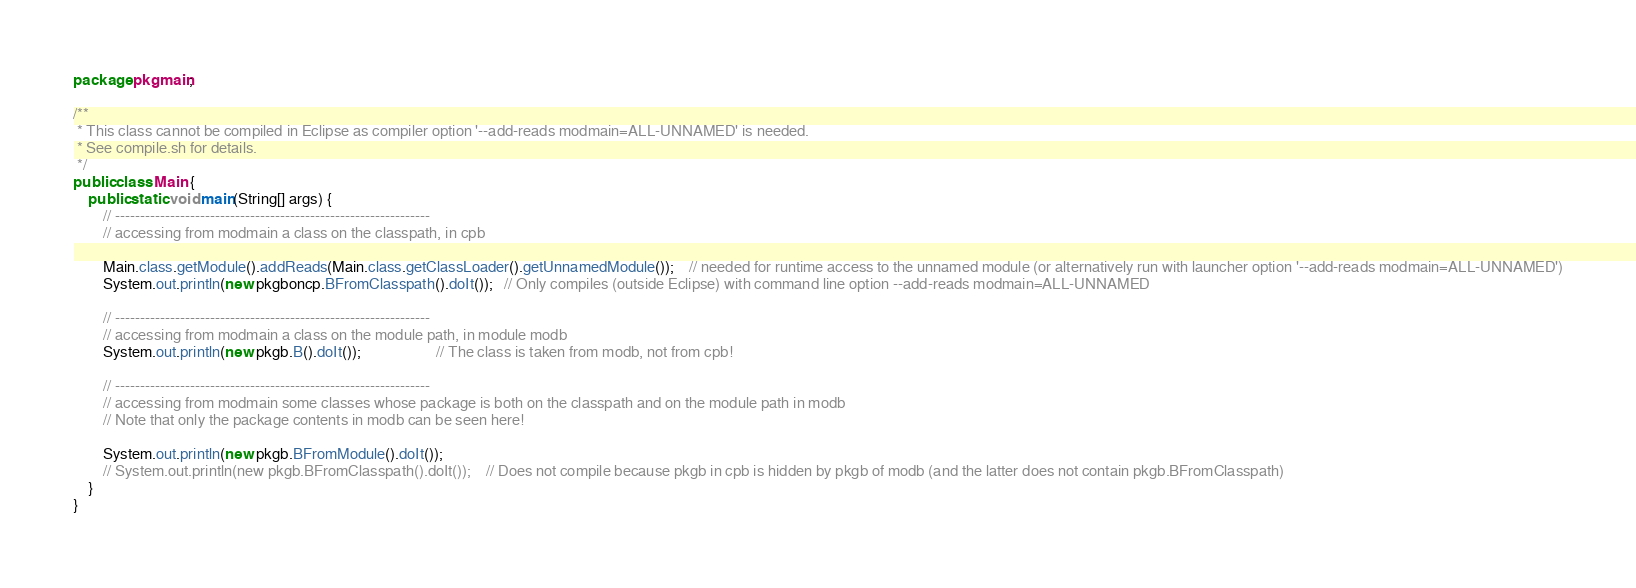<code> <loc_0><loc_0><loc_500><loc_500><_Java_>package pkgmain;

/**
 * This class cannot be compiled in Eclipse as compiler option '--add-reads modmain=ALL-UNNAMED' is needed.
 * See compile.sh for details. 
 */
public class Main {
    public static void main(String[] args) {
        // ---------------------------------------------------------------
    	// accessing from modmain a class on the classpath, in cpb
        
    	Main.class.getModule().addReads(Main.class.getClassLoader().getUnnamedModule());	// needed for runtime access to the unnamed module (or alternatively run with launcher option '--add-reads modmain=ALL-UNNAMED')
    	System.out.println(new pkgboncp.BFromClasspath().doIt());   // Only compiles (outside Eclipse) with command line option --add-reads modmain=ALL-UNNAMED 
    	
        // ---------------------------------------------------------------
        // accessing from modmain a class on the module path, in module modb        
        System.out.println(new pkgb.B().doIt());					// The class is taken from modb, not from cpb!

        // ---------------------------------------------------------------
        // accessing from modmain some classes whose package is both on the classpath and on the module path in modb
        // Note that only the package contents in modb can be seen here!

        System.out.println(new pkgb.BFromModule().doIt());
        // System.out.println(new pkgb.BFromClasspath().doIt());    // Does not compile because pkgb in cpb is hidden by pkgb of modb (and the latter does not contain pkgb.BFromClasspath)
    }
}
</code> 